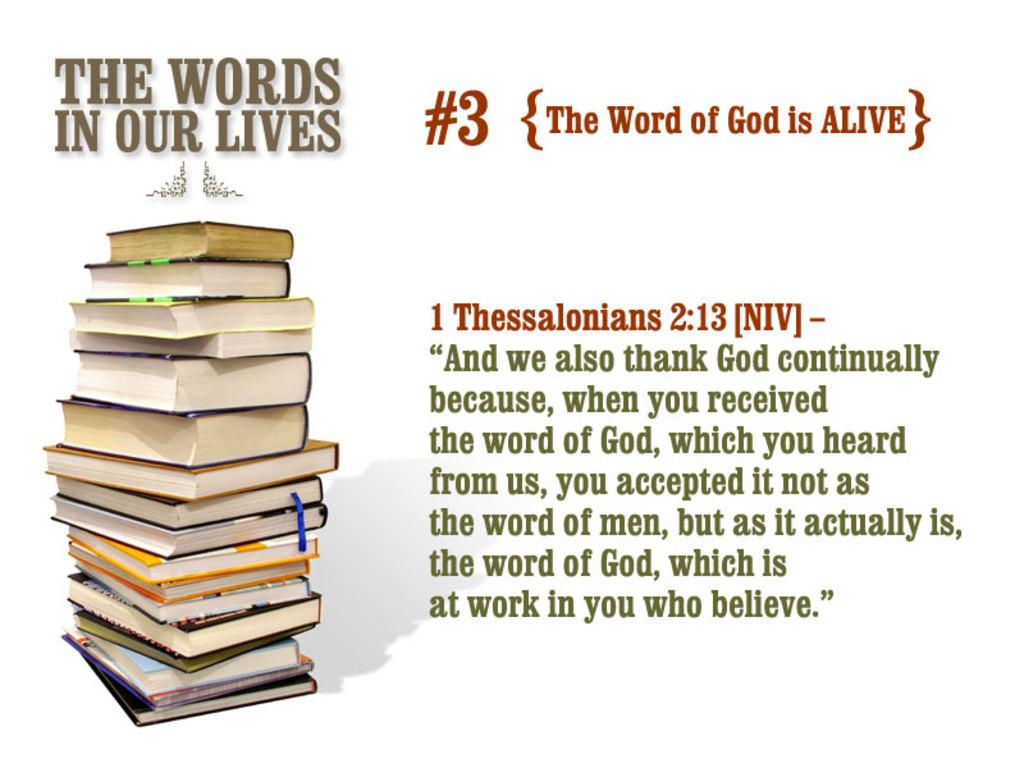<image>
Present a compact description of the photo's key features. A stack of books with the words above that say The Words In Our Lives. 